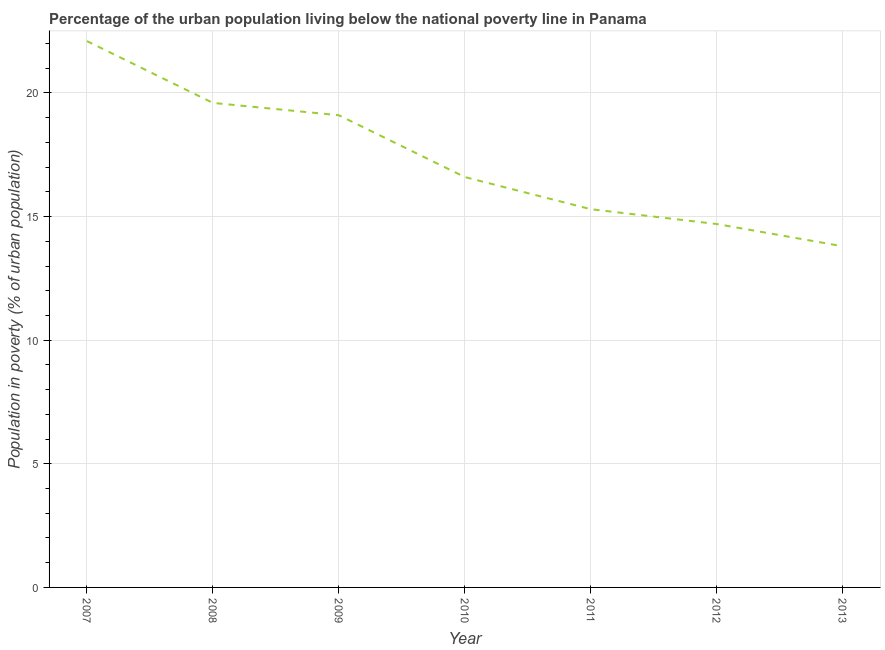Across all years, what is the maximum percentage of urban population living below poverty line?
Provide a succinct answer. 22.1. Across all years, what is the minimum percentage of urban population living below poverty line?
Make the answer very short. 13.8. In which year was the percentage of urban population living below poverty line maximum?
Your response must be concise. 2007. In which year was the percentage of urban population living below poverty line minimum?
Keep it short and to the point. 2013. What is the sum of the percentage of urban population living below poverty line?
Make the answer very short. 121.2. What is the difference between the percentage of urban population living below poverty line in 2010 and 2012?
Provide a short and direct response. 1.9. What is the average percentage of urban population living below poverty line per year?
Provide a short and direct response. 17.31. What is the median percentage of urban population living below poverty line?
Keep it short and to the point. 16.6. What is the ratio of the percentage of urban population living below poverty line in 2007 to that in 2008?
Provide a succinct answer. 1.13. Is the percentage of urban population living below poverty line in 2008 less than that in 2011?
Give a very brief answer. No. Is the sum of the percentage of urban population living below poverty line in 2008 and 2013 greater than the maximum percentage of urban population living below poverty line across all years?
Offer a very short reply. Yes. How many lines are there?
Offer a terse response. 1. What is the difference between two consecutive major ticks on the Y-axis?
Offer a terse response. 5. Are the values on the major ticks of Y-axis written in scientific E-notation?
Your response must be concise. No. Does the graph contain grids?
Ensure brevity in your answer.  Yes. What is the title of the graph?
Provide a succinct answer. Percentage of the urban population living below the national poverty line in Panama. What is the label or title of the X-axis?
Your answer should be compact. Year. What is the label or title of the Y-axis?
Provide a succinct answer. Population in poverty (% of urban population). What is the Population in poverty (% of urban population) of 2007?
Your answer should be very brief. 22.1. What is the Population in poverty (% of urban population) of 2008?
Provide a succinct answer. 19.6. What is the Population in poverty (% of urban population) of 2009?
Your answer should be very brief. 19.1. What is the Population in poverty (% of urban population) in 2011?
Give a very brief answer. 15.3. What is the difference between the Population in poverty (% of urban population) in 2007 and 2008?
Provide a short and direct response. 2.5. What is the difference between the Population in poverty (% of urban population) in 2007 and 2010?
Ensure brevity in your answer.  5.5. What is the difference between the Population in poverty (% of urban population) in 2007 and 2011?
Make the answer very short. 6.8. What is the difference between the Population in poverty (% of urban population) in 2007 and 2012?
Offer a terse response. 7.4. What is the difference between the Population in poverty (% of urban population) in 2007 and 2013?
Offer a terse response. 8.3. What is the difference between the Population in poverty (% of urban population) in 2008 and 2013?
Your answer should be very brief. 5.8. What is the difference between the Population in poverty (% of urban population) in 2009 and 2010?
Your answer should be compact. 2.5. What is the difference between the Population in poverty (% of urban population) in 2009 and 2011?
Give a very brief answer. 3.8. What is the difference between the Population in poverty (% of urban population) in 2009 and 2013?
Offer a terse response. 5.3. What is the difference between the Population in poverty (% of urban population) in 2010 and 2013?
Make the answer very short. 2.8. What is the difference between the Population in poverty (% of urban population) in 2011 and 2012?
Provide a short and direct response. 0.6. What is the difference between the Population in poverty (% of urban population) in 2011 and 2013?
Your answer should be compact. 1.5. What is the ratio of the Population in poverty (% of urban population) in 2007 to that in 2008?
Your answer should be very brief. 1.13. What is the ratio of the Population in poverty (% of urban population) in 2007 to that in 2009?
Give a very brief answer. 1.16. What is the ratio of the Population in poverty (% of urban population) in 2007 to that in 2010?
Provide a succinct answer. 1.33. What is the ratio of the Population in poverty (% of urban population) in 2007 to that in 2011?
Give a very brief answer. 1.44. What is the ratio of the Population in poverty (% of urban population) in 2007 to that in 2012?
Keep it short and to the point. 1.5. What is the ratio of the Population in poverty (% of urban population) in 2007 to that in 2013?
Give a very brief answer. 1.6. What is the ratio of the Population in poverty (% of urban population) in 2008 to that in 2009?
Your response must be concise. 1.03. What is the ratio of the Population in poverty (% of urban population) in 2008 to that in 2010?
Give a very brief answer. 1.18. What is the ratio of the Population in poverty (% of urban population) in 2008 to that in 2011?
Your response must be concise. 1.28. What is the ratio of the Population in poverty (% of urban population) in 2008 to that in 2012?
Provide a succinct answer. 1.33. What is the ratio of the Population in poverty (% of urban population) in 2008 to that in 2013?
Your answer should be compact. 1.42. What is the ratio of the Population in poverty (% of urban population) in 2009 to that in 2010?
Make the answer very short. 1.15. What is the ratio of the Population in poverty (% of urban population) in 2009 to that in 2011?
Provide a short and direct response. 1.25. What is the ratio of the Population in poverty (% of urban population) in 2009 to that in 2012?
Your answer should be compact. 1.3. What is the ratio of the Population in poverty (% of urban population) in 2009 to that in 2013?
Provide a succinct answer. 1.38. What is the ratio of the Population in poverty (% of urban population) in 2010 to that in 2011?
Your answer should be compact. 1.08. What is the ratio of the Population in poverty (% of urban population) in 2010 to that in 2012?
Offer a terse response. 1.13. What is the ratio of the Population in poverty (% of urban population) in 2010 to that in 2013?
Give a very brief answer. 1.2. What is the ratio of the Population in poverty (% of urban population) in 2011 to that in 2012?
Your answer should be compact. 1.04. What is the ratio of the Population in poverty (% of urban population) in 2011 to that in 2013?
Your response must be concise. 1.11. What is the ratio of the Population in poverty (% of urban population) in 2012 to that in 2013?
Keep it short and to the point. 1.06. 